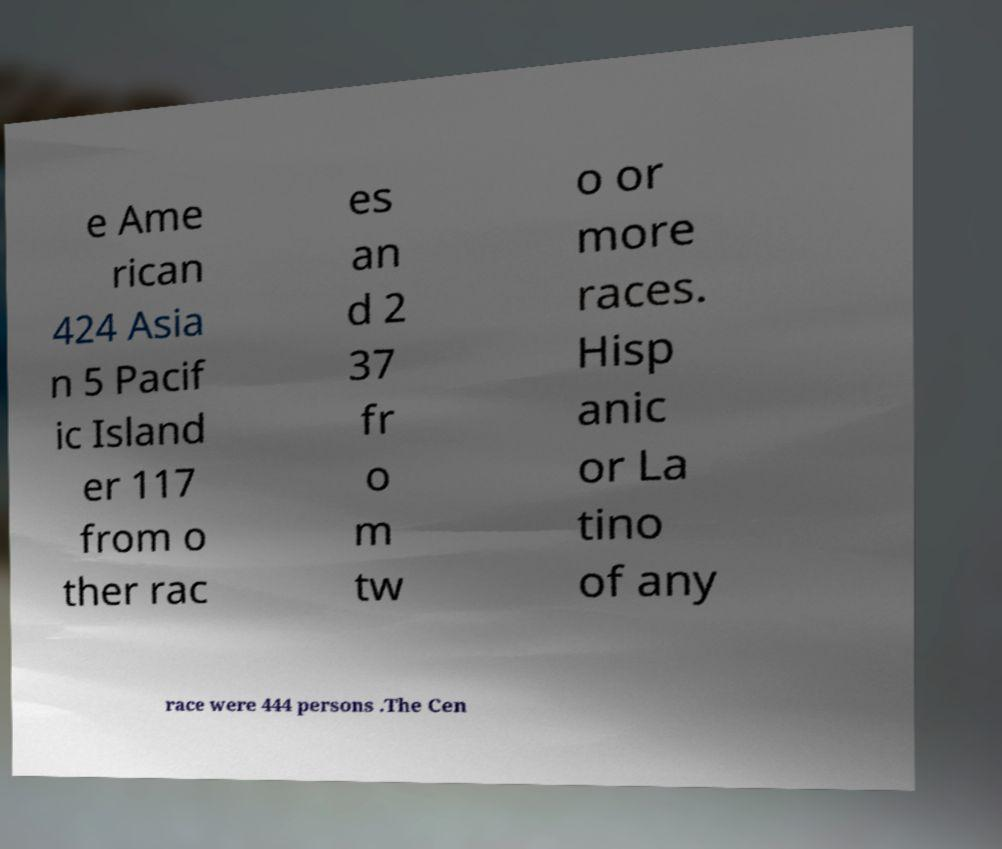There's text embedded in this image that I need extracted. Can you transcribe it verbatim? e Ame rican 424 Asia n 5 Pacif ic Island er 117 from o ther rac es an d 2 37 fr o m tw o or more races. Hisp anic or La tino of any race were 444 persons .The Cen 